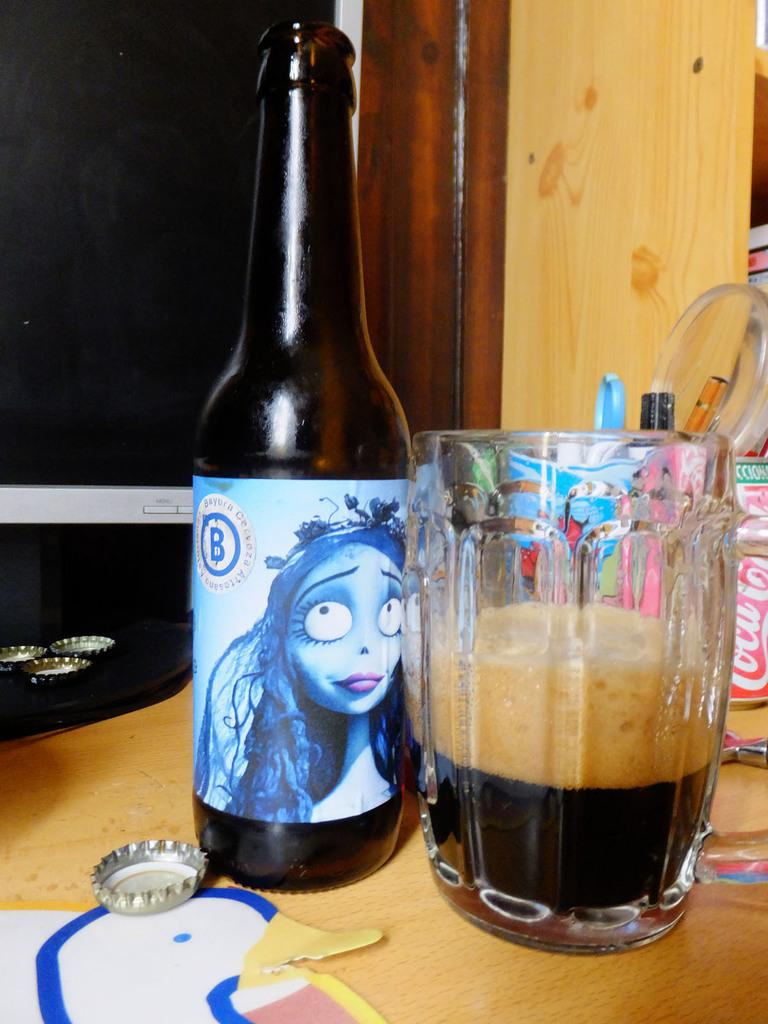<image>
Create a compact narrative representing the image presented. A bottle of Bayura Cerveza beer sits next to a glass on a desk. 